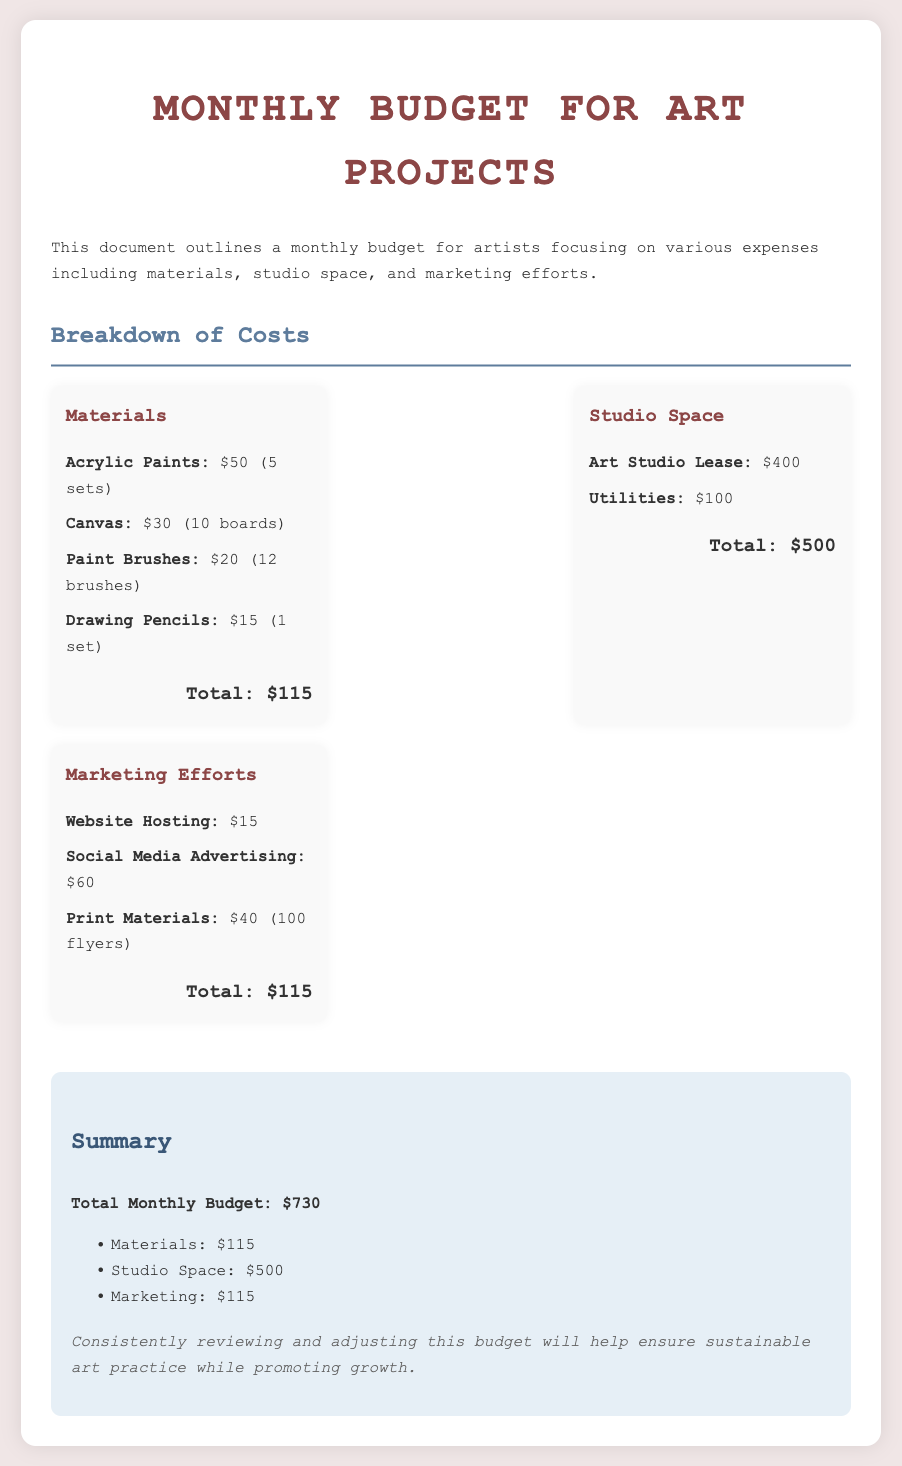what is the total monthly budget? The total monthly budget is outlined in the summary section, reflecting all expenses.
Answer: $730 how much is allocated for studio space? The studio space costs are detailed in the breakdown section.
Answer: $500 what is the cost of acrylic paints? The cost of acrylic paints is listed under the materials section.
Answer: $50 how many canvases are included in the materials cost? The number of canvases is specified in the materials cost breakdown.
Answer: 10 boards what amount is budgeted for marketing efforts? The total for marketing efforts is found in the breakdown section.
Answer: $115 how much is spent on utilities? Utilities are specifically listed in the studio space expenses.
Answer: $100 what is included in the marketing efforts section? The marketing efforts section describes various activities and their associated costs.
Answer: Website Hosting, Social Media Advertising, Print Materials what is the total cost for materials? The total cost for materials sums all items listed in that section.
Answer: $115 how many paint brushes are included? The number of paint brushes is explicitly stated in the materials cost section.
Answer: 12 brushes 